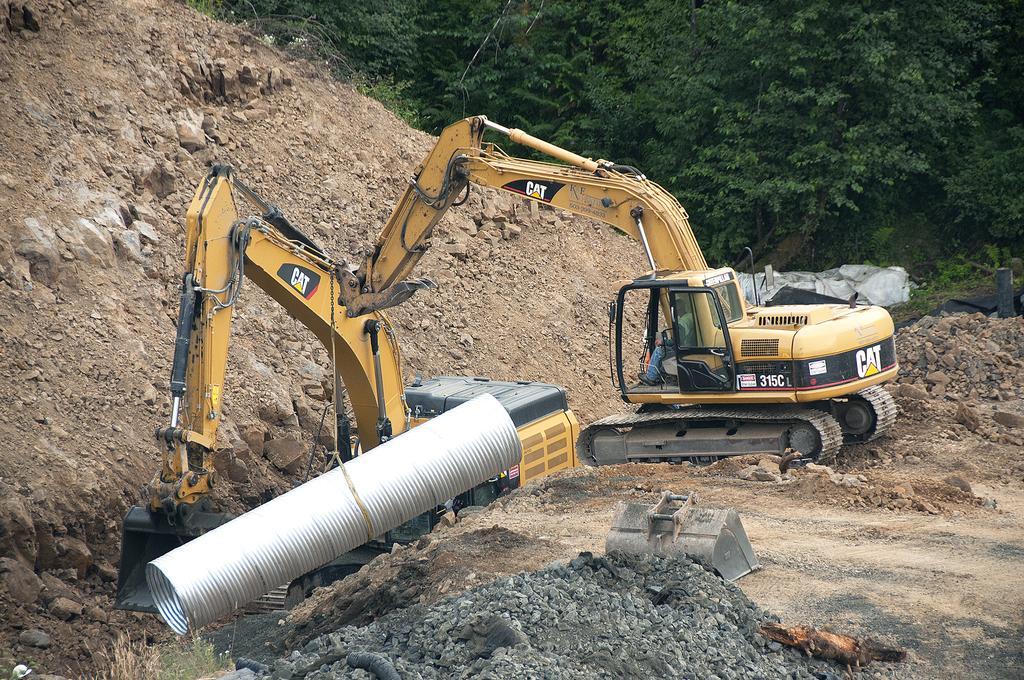Could you give a brief overview of what you see in this image? There are two cranes present in the middle of this image. one crane is holding an object. There is a sand surface in the background. There are some trees at the top of this image. 